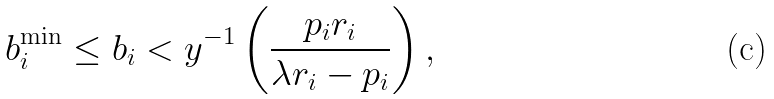Convert formula to latex. <formula><loc_0><loc_0><loc_500><loc_500>b _ { i } ^ { \min } \leq b _ { i } < y ^ { - 1 } \left ( \frac { p _ { i } r _ { i } } { \lambda r _ { i } - p _ { i } } \right ) ,</formula> 